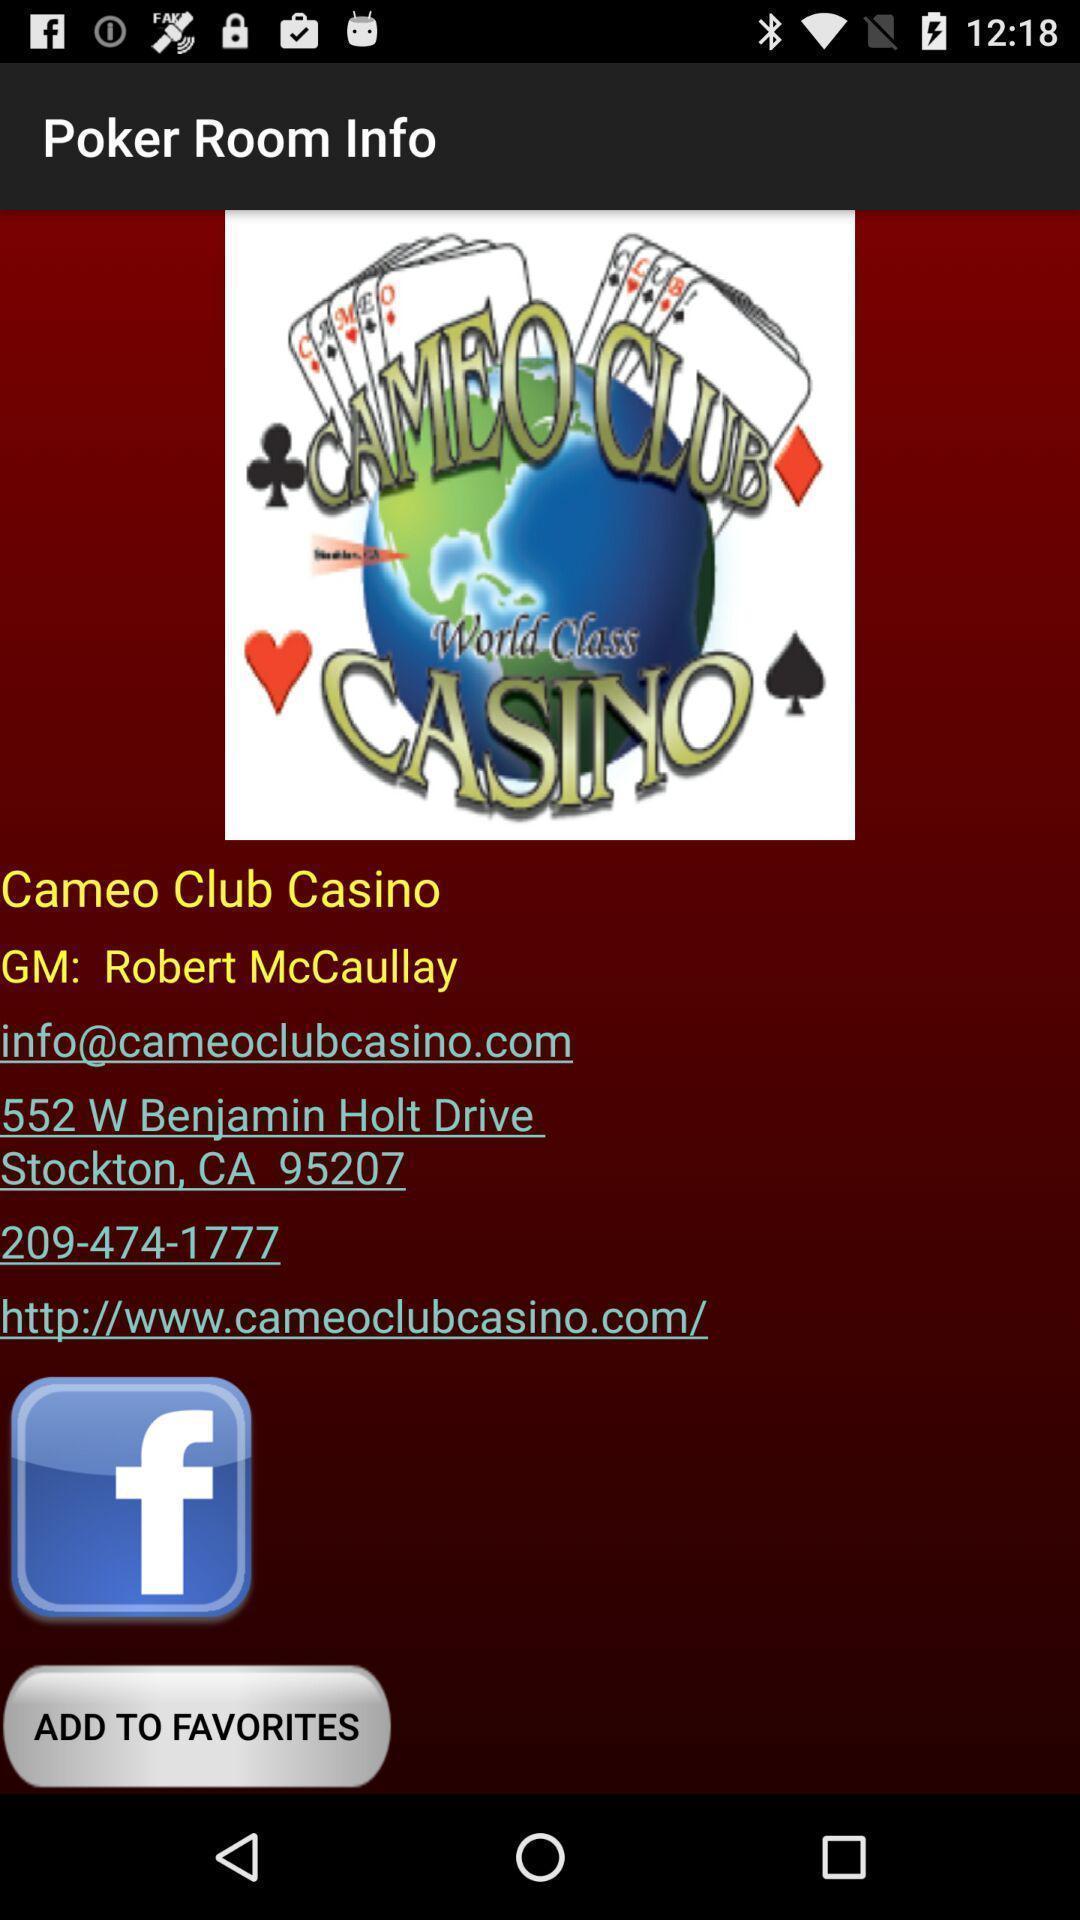Describe the key features of this screenshot. Page showing game details in a gaming website. 